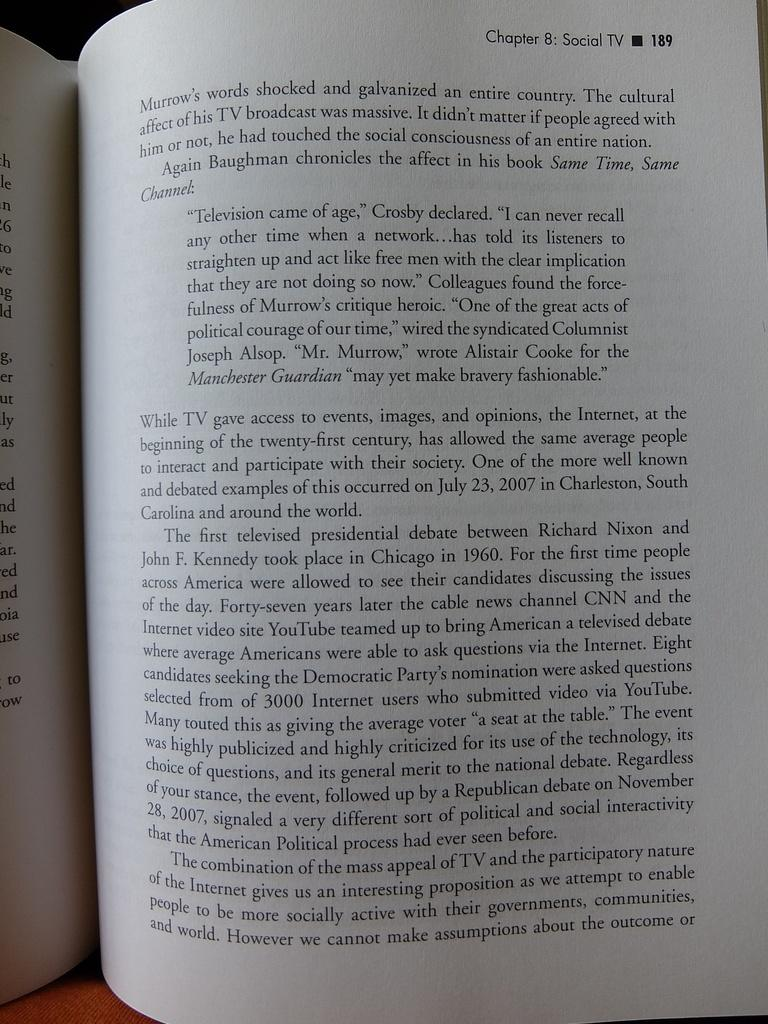What object can be seen in the image? There is a book in the image. What can be found on the pages of the book? There is text visible in the image. What type of ship is sailing in the background of the image? There is no ship present in the image; it only features a book with text. 